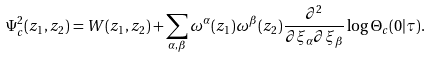<formula> <loc_0><loc_0><loc_500><loc_500>\Psi _ { c } ^ { 2 } ( z _ { 1 } , z _ { 2 } ) = W ( z _ { 1 } , z _ { 2 } ) + \sum _ { \alpha , \beta } \omega ^ { \alpha } ( z _ { 1 } ) \omega ^ { \beta } ( z _ { 2 } ) \frac { \partial ^ { 2 } } { \partial \xi _ { \alpha } \partial \xi _ { \beta } } \log \Theta _ { c } ( 0 | \tau ) .</formula> 